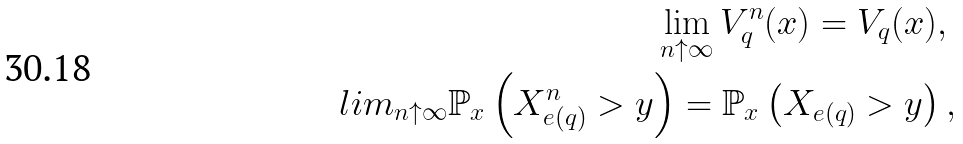Convert formula to latex. <formula><loc_0><loc_0><loc_500><loc_500>\lim _ { n \uparrow \infty } V _ { q } ^ { n } ( x ) = V _ { q } ( x ) , \ \\ l i m _ { n \uparrow \infty } \mathbb { P } _ { x } \left ( X ^ { n } _ { e ( q ) } > y \right ) = \mathbb { P } _ { x } \left ( X _ { e ( q ) } > y \right ) ,</formula> 